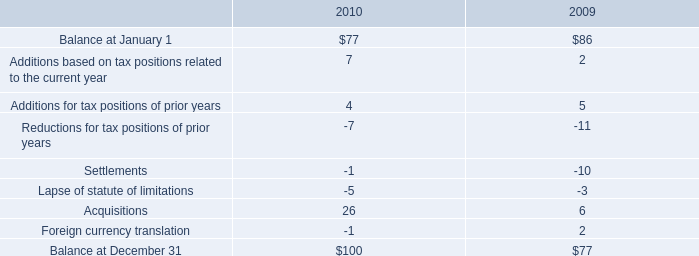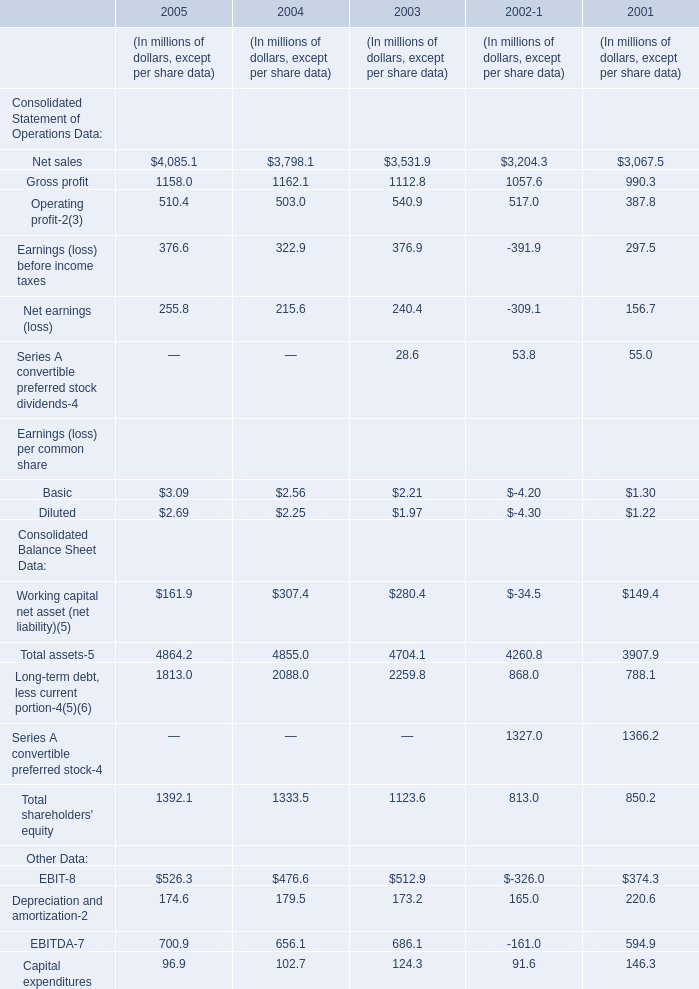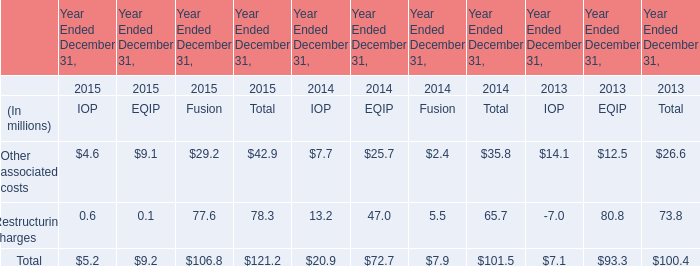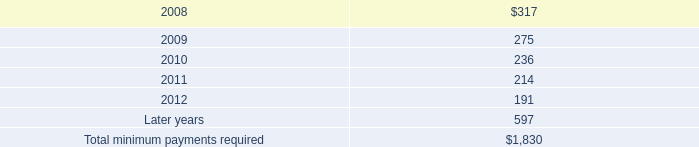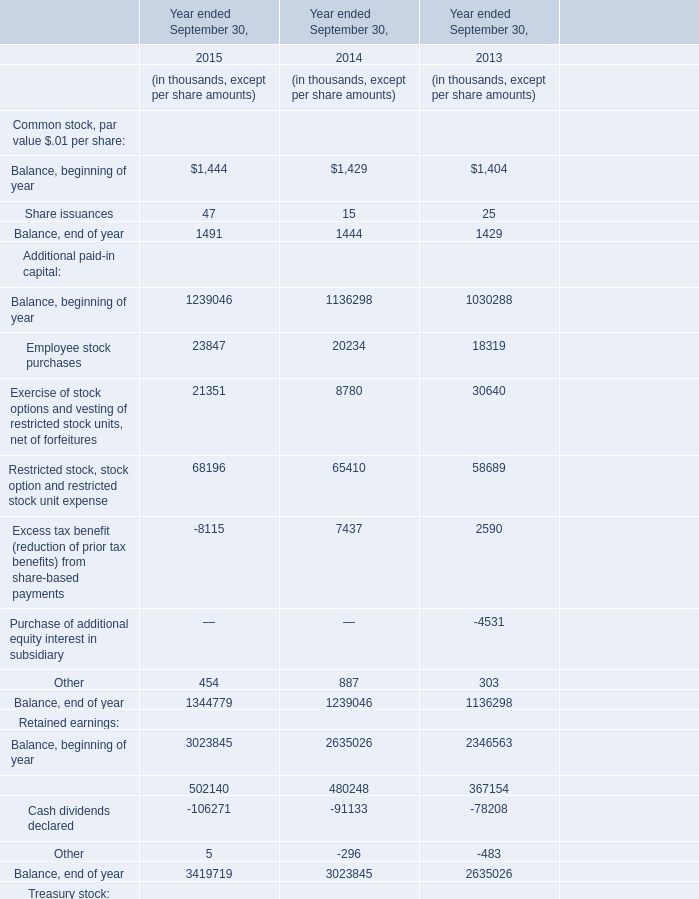What was the average value of the Purchases/surrenders of Treasury stock? in the years where Excess tax benefit (reduction of prior tax benefits) from share-based payments is positive? (in thousand) 
Computations: ((-2173 - 8214) / 2)
Answer: -5193.5. 